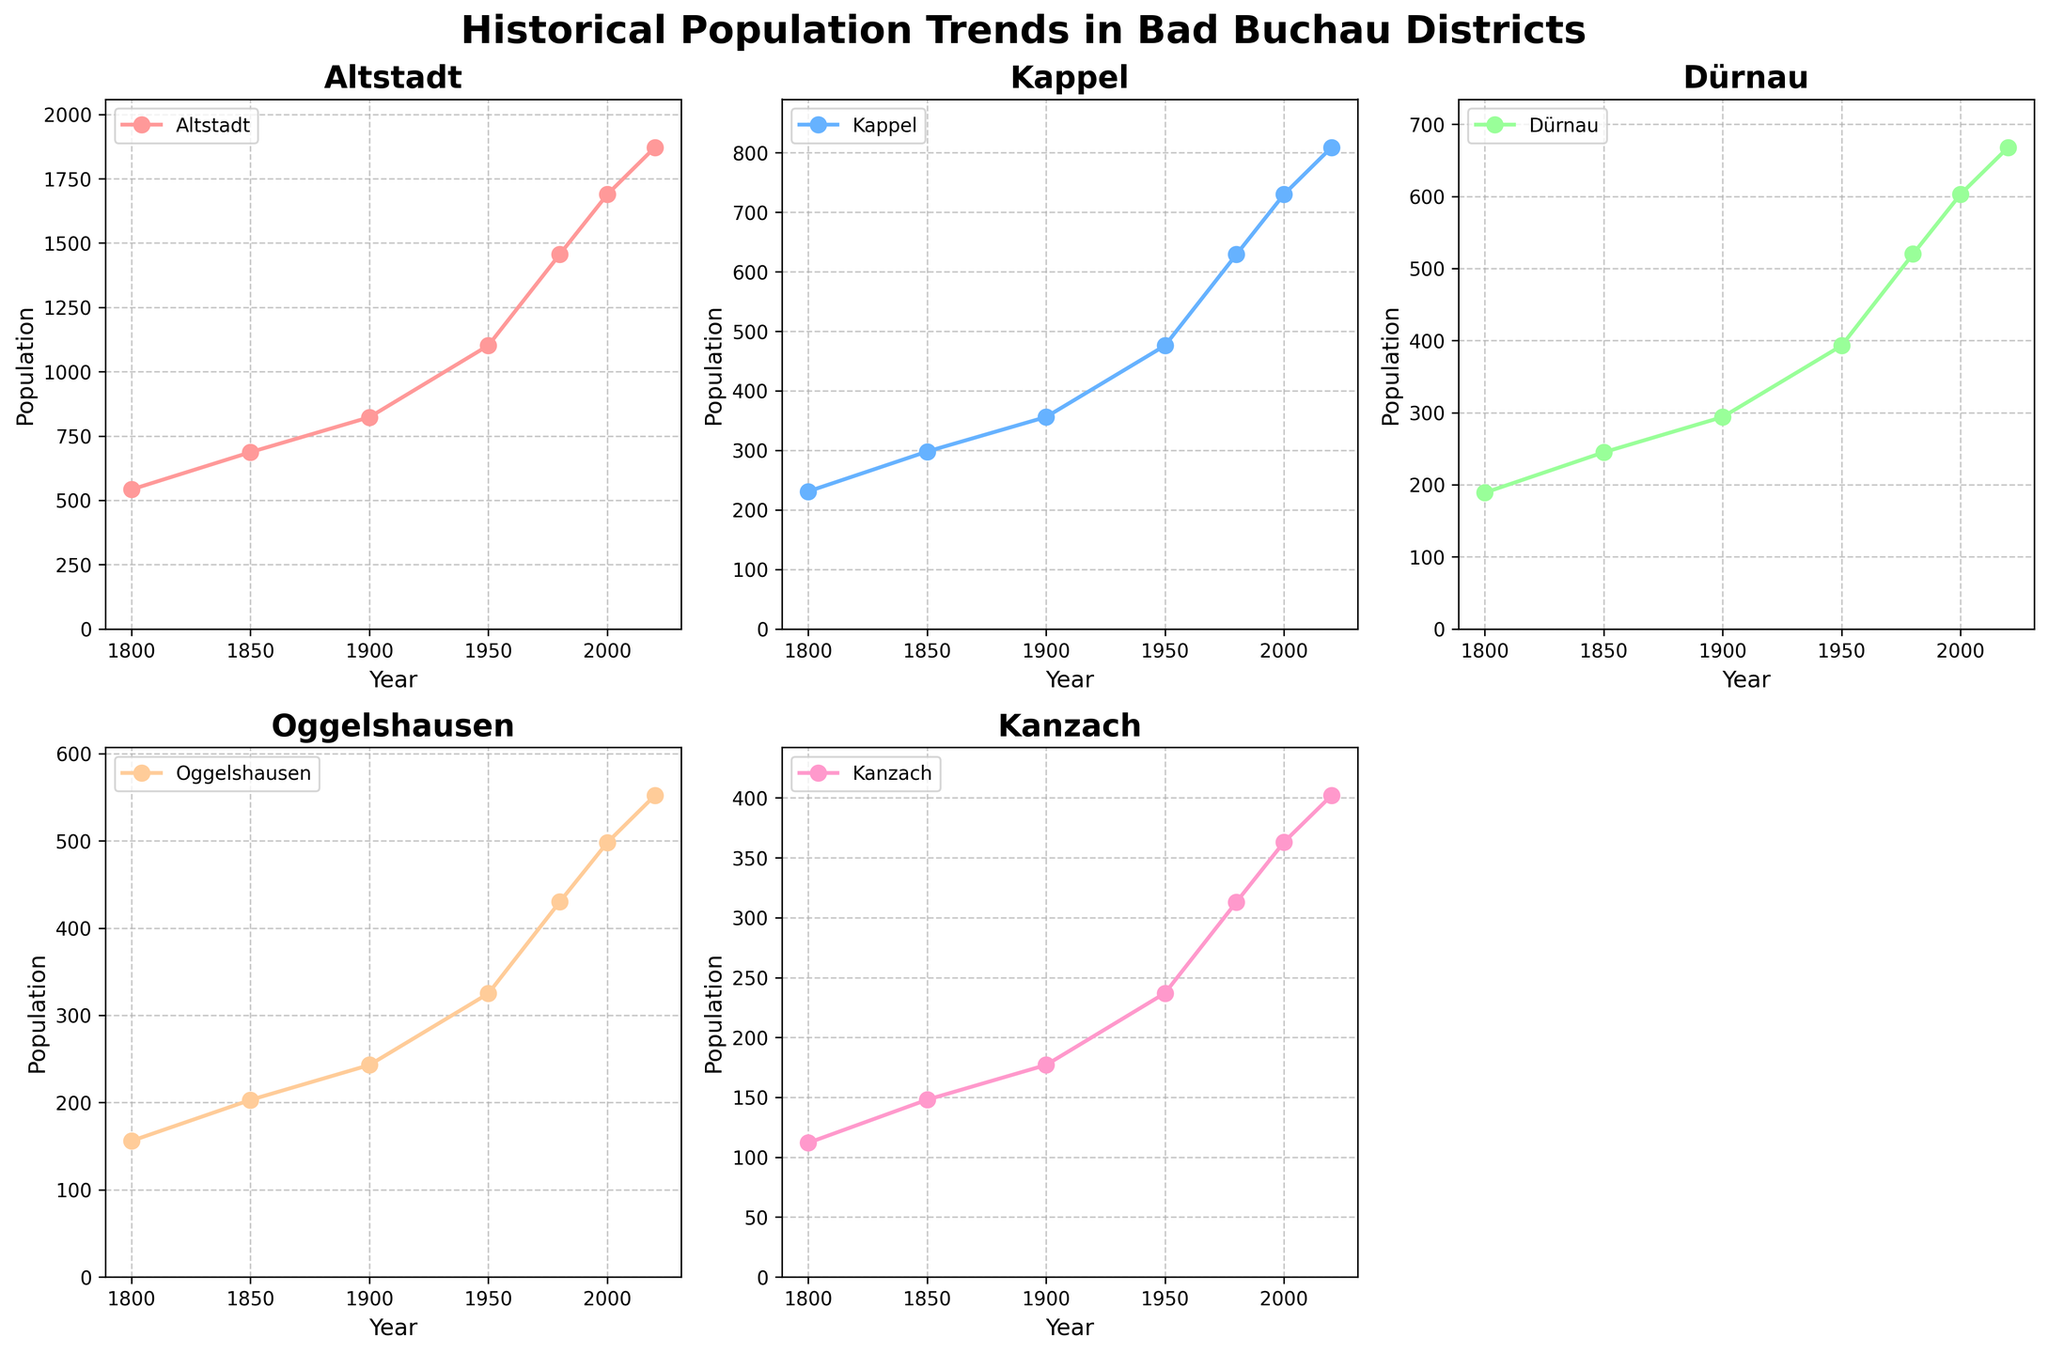What's the title of the figure? The title of the figure is found at the top and reads "Historical Population Trends in Bad Buchau Districts" in bold.
Answer: Historical Population Trends in Bad Buchau Districts How many subplots display population trends? There are 5 subplots since one of the spaces (the last subplot) is removed. Part of the grid arrangement (2 rows x 3 columns) has space for 6 plots, but only 5 districts are shown.
Answer: 5 Which district had the highest population in 2000? By observing the y-axis and markers for different districts in 2000, the subplot for 'Altstadt' shows the highest value.
Answer: Altstadt What was the population of Kanzach in 1800 and 2020? The population values are seen on the y-axis at the markers for the years 1800 and 2020 in the Kanzach subplot. In 1800 it's 112, and in 2020 it's 402.
Answer: 112, 402 Which district experienced the most significant population growth between 1800 and 2020? We calculate the difference between the population values in 2020 and 1800 for each district, and the largest difference is found in 'Altstadt'.
Answer: Altstadt What is the average population of Dürnau from the years shown? The population values for Dürnau are: 189, 245, 294, 393, 520, 603, 668. Averaging these (sum/7), (189 + 245 + 294 + 393 + 520 + 603 + 668) / 7 = 416.
Answer: 416 Which district had the least population growth between 1980 and 2020? We compute the difference between the population values in 2020 and 1980 for each district. The smallest difference is found in 'Kanzach'.
Answer: Kanzach Which district showed a steady increase in population over time with no decreases in any period? Observing the line plots of each subplot, all districts show an increase, but no decreases are seen in any district's trend.
Answer: All districts In which period did Oggelshausen experience the fastest population growth? Comparing the slopes of the line segments in Oggelshausen's subplot, the largest increase occurs from 1950 to 1980.
Answer: 1950-1980 What is the difference in the population of Kappel between 1850 and 2000? Subtract the population of Kappel in 1850 from that in 2000: 730 - 298 = 432.
Answer: 432 